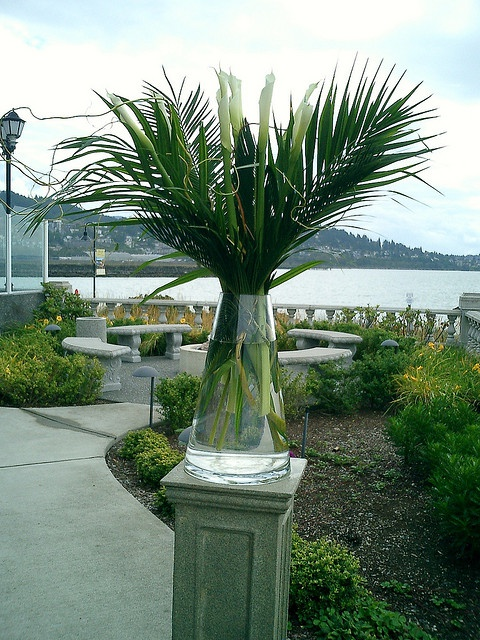Describe the objects in this image and their specific colors. I can see potted plant in lightblue, white, black, darkgreen, and teal tones, vase in lightblue, gray, ivory, black, and darkgreen tones, bench in lightblue, darkgray, gray, black, and darkgreen tones, bench in lightblue, gray, darkgray, and lightgray tones, and bench in lightblue, gray, darkgray, and lightgray tones in this image. 